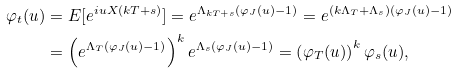<formula> <loc_0><loc_0><loc_500><loc_500>\varphi _ { t } ( u ) & = E [ e ^ { i u X ( k T + s ) } ] = e ^ { \Lambda _ { k T + s } ( \varphi _ { J } ( u ) - 1 ) } = e ^ { ( k \Lambda _ { T } + \Lambda _ { s } ) ( \varphi _ { J } ( u ) - 1 ) } \\ & = \left ( e ^ { \Lambda _ { T } ( \varphi _ { J } ( u ) - 1 ) } \right ) ^ { k } e ^ { \Lambda _ { s } ( \varphi _ { J } ( u ) - 1 ) } = \left ( \varphi _ { T } ( u ) \right ) ^ { k } \varphi _ { s } ( u ) ,</formula> 